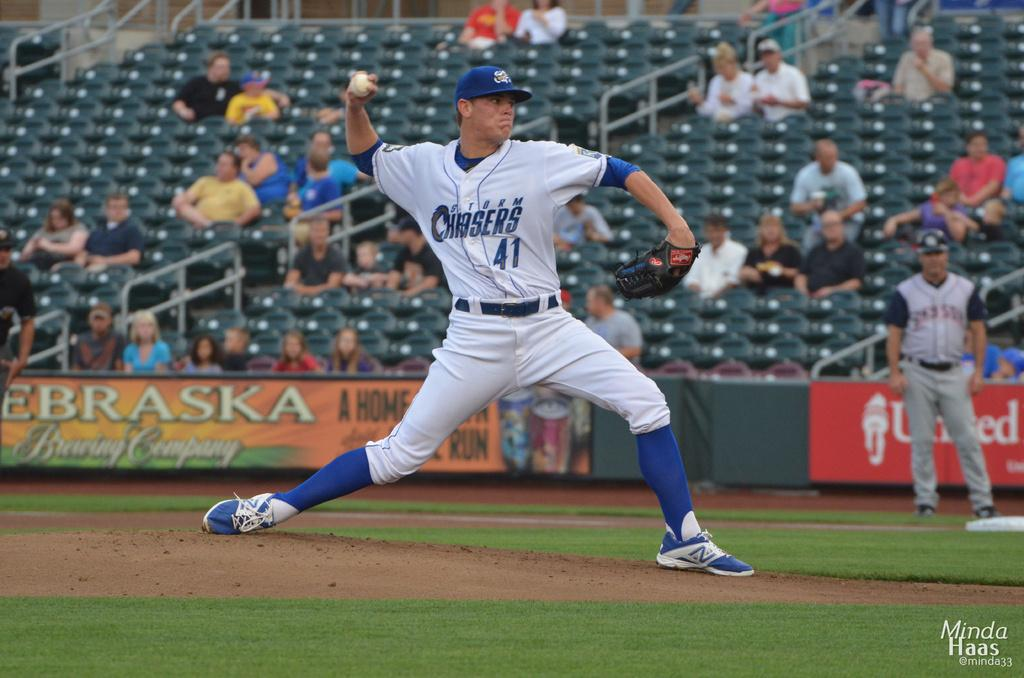<image>
Write a terse but informative summary of the picture. a player that is throwing a ball and is from the Chasers 